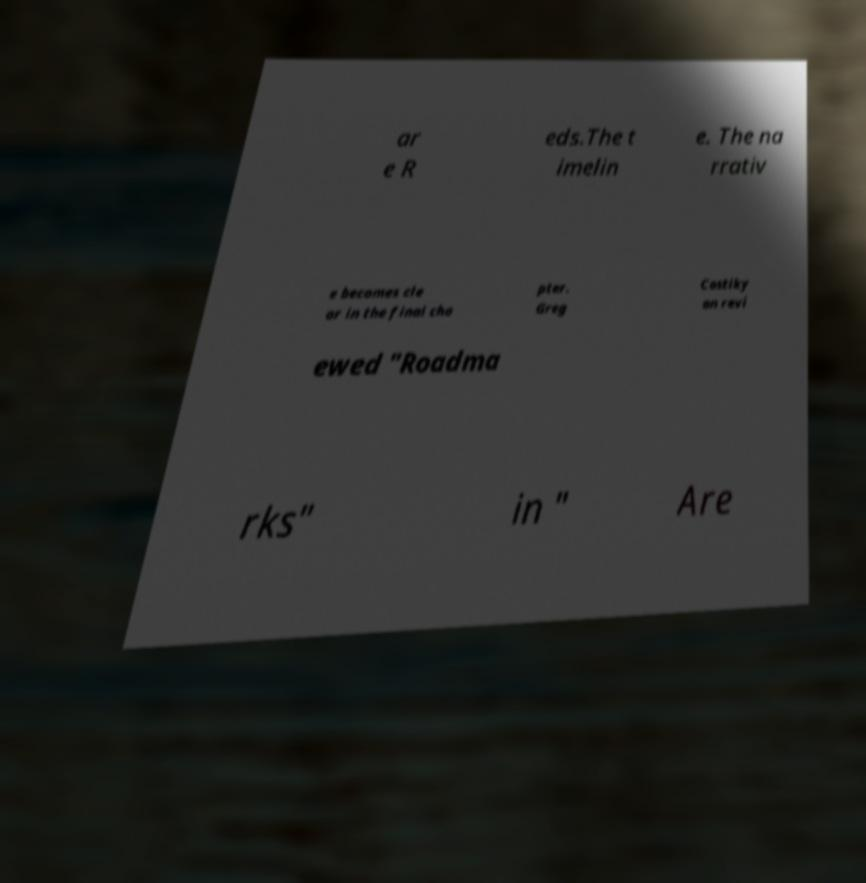Can you accurately transcribe the text from the provided image for me? ar e R eds.The t imelin e. The na rrativ e becomes cle ar in the final cha pter. Greg Costiky an revi ewed "Roadma rks" in " Are 